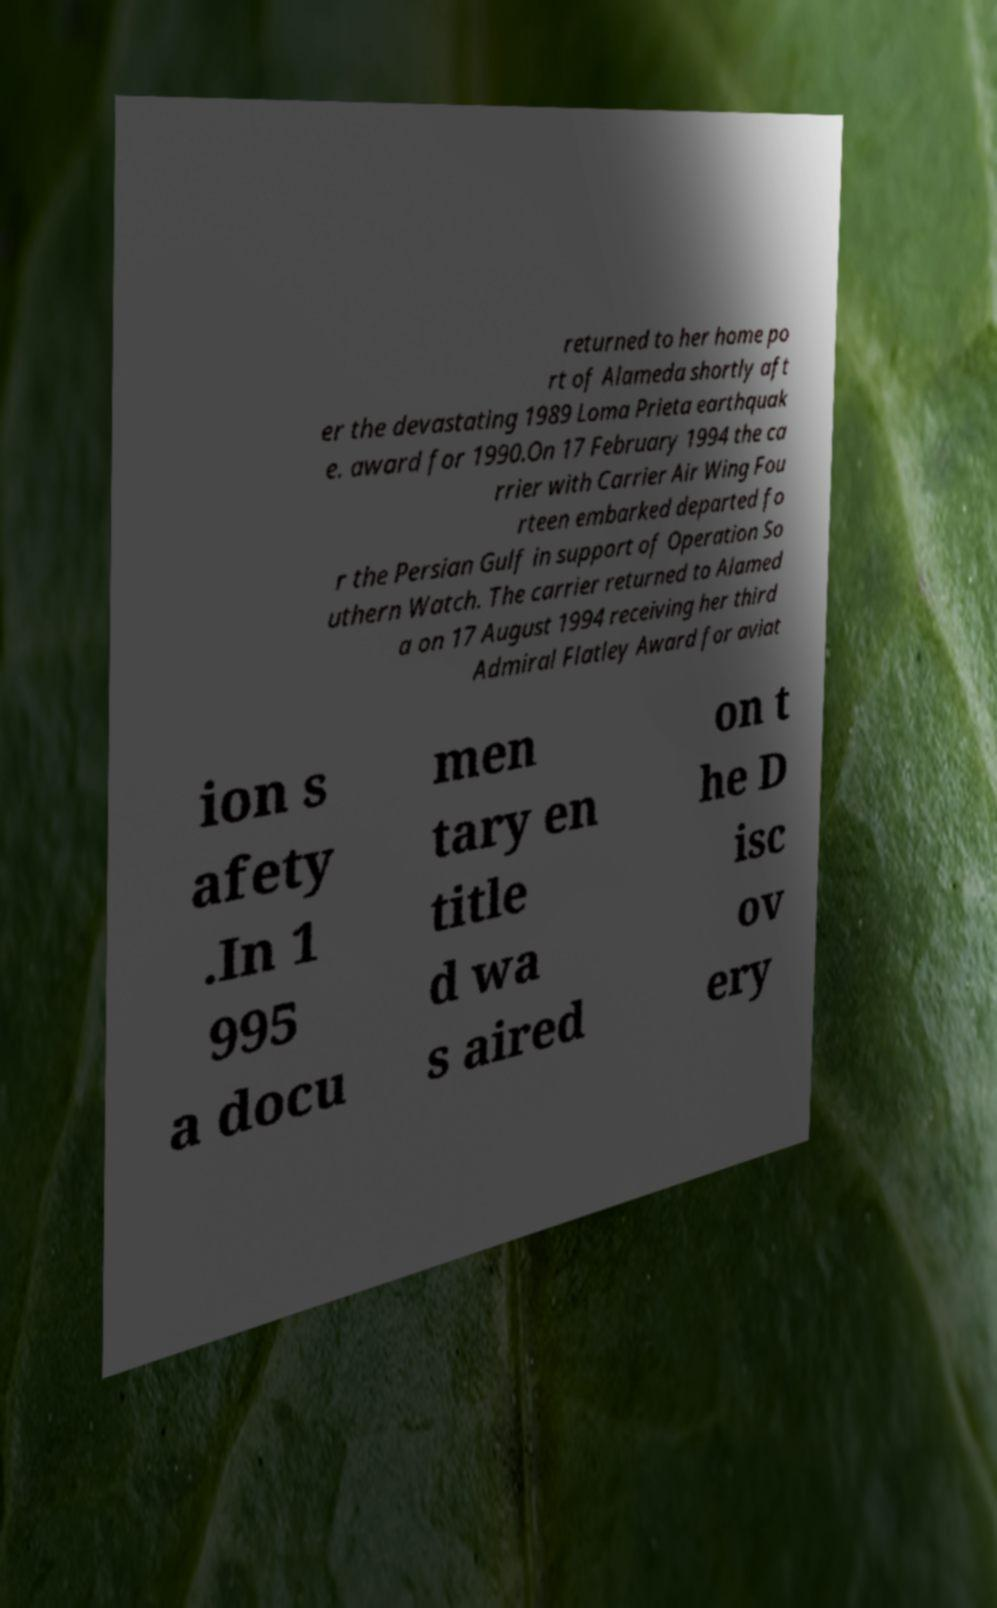For documentation purposes, I need the text within this image transcribed. Could you provide that? returned to her home po rt of Alameda shortly aft er the devastating 1989 Loma Prieta earthquak e. award for 1990.On 17 February 1994 the ca rrier with Carrier Air Wing Fou rteen embarked departed fo r the Persian Gulf in support of Operation So uthern Watch. The carrier returned to Alamed a on 17 August 1994 receiving her third Admiral Flatley Award for aviat ion s afety .In 1 995 a docu men tary en title d wa s aired on t he D isc ov ery 